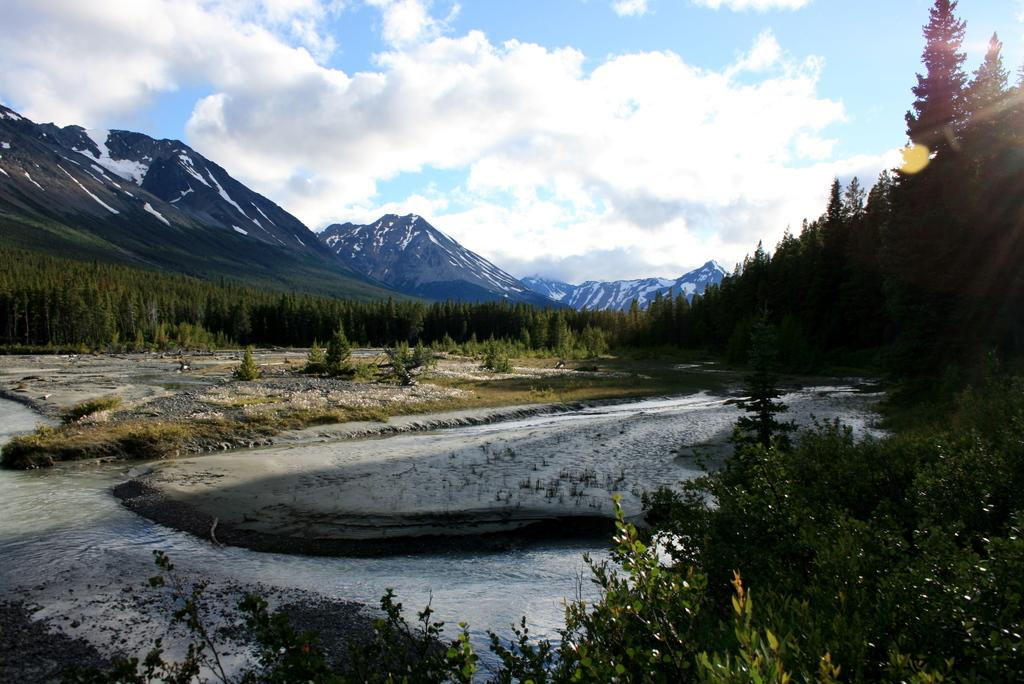What type of natural landscape is depicted in the image? The image features mountains covered with snow. What other natural elements can be seen in the image? There are plants, trees, water, and grass visible in the image. What is the condition of the sky in the image? The sky in the image contains clouds. How many children are playing with a pear in the image? There are no children or pear present in the image. What type of parent is supervising the children in the image? There are no children or parent present in the image. 